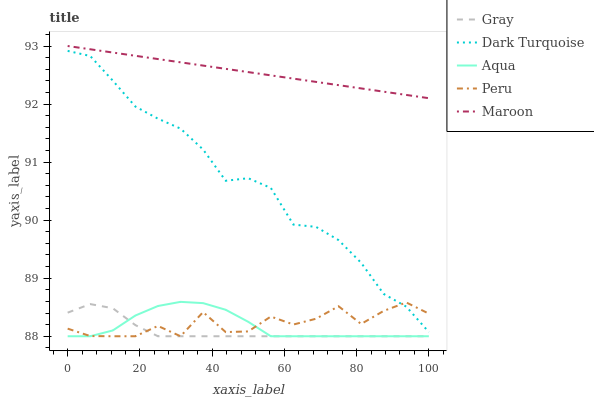Does Gray have the minimum area under the curve?
Answer yes or no. Yes. Does Maroon have the maximum area under the curve?
Answer yes or no. Yes. Does Aqua have the minimum area under the curve?
Answer yes or no. No. Does Aqua have the maximum area under the curve?
Answer yes or no. No. Is Maroon the smoothest?
Answer yes or no. Yes. Is Peru the roughest?
Answer yes or no. Yes. Is Aqua the smoothest?
Answer yes or no. No. Is Aqua the roughest?
Answer yes or no. No. Does Gray have the lowest value?
Answer yes or no. Yes. Does Maroon have the lowest value?
Answer yes or no. No. Does Maroon have the highest value?
Answer yes or no. Yes. Does Aqua have the highest value?
Answer yes or no. No. Is Aqua less than Dark Turquoise?
Answer yes or no. Yes. Is Maroon greater than Peru?
Answer yes or no. Yes. Does Peru intersect Aqua?
Answer yes or no. Yes. Is Peru less than Aqua?
Answer yes or no. No. Is Peru greater than Aqua?
Answer yes or no. No. Does Aqua intersect Dark Turquoise?
Answer yes or no. No. 